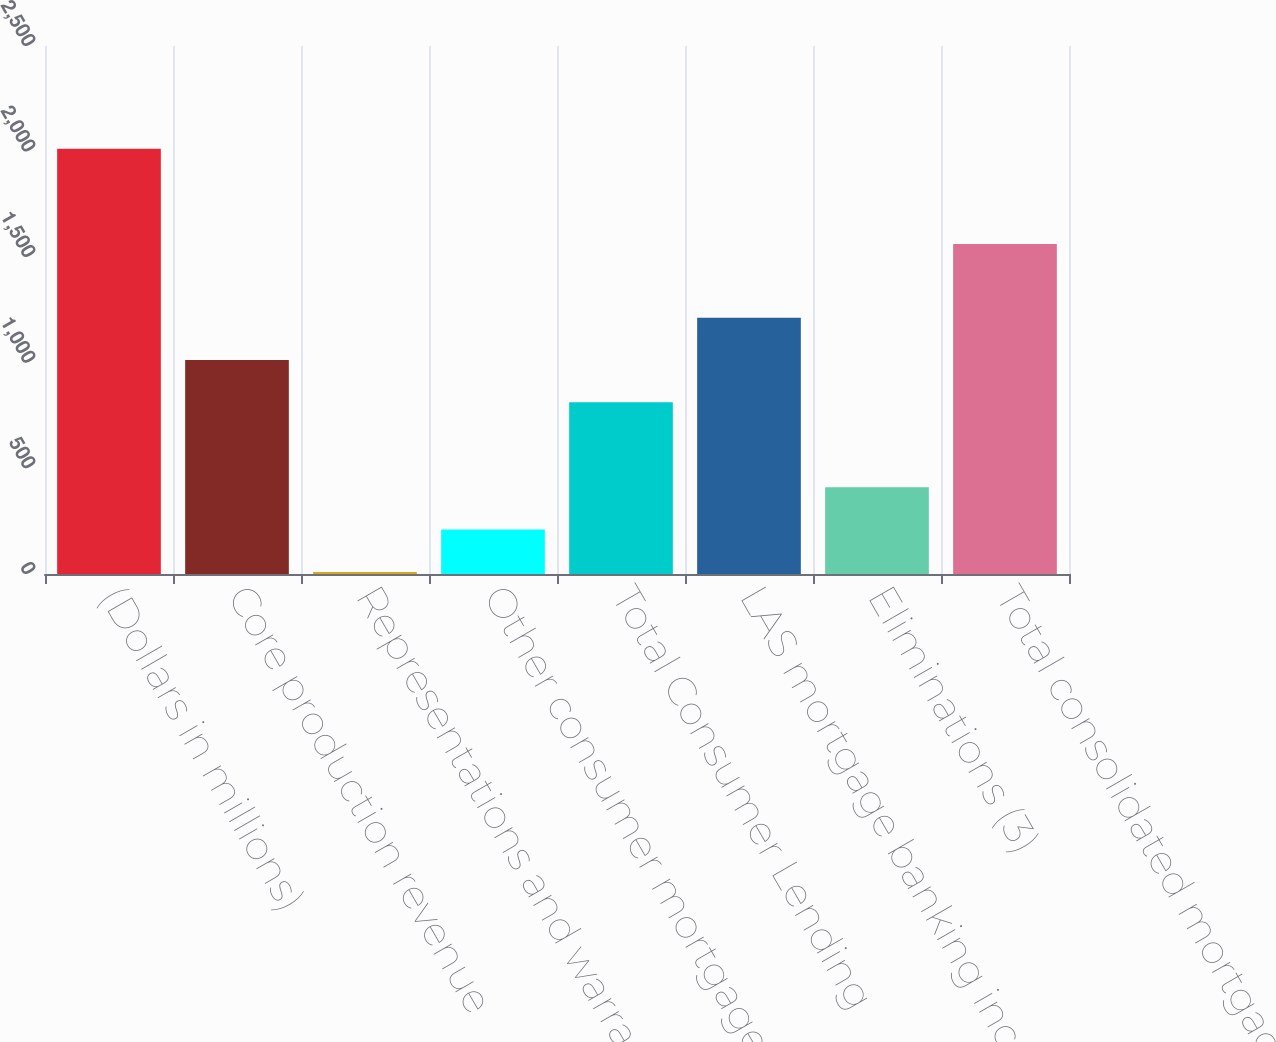<chart> <loc_0><loc_0><loc_500><loc_500><bar_chart><fcel>(Dollars in millions)<fcel>Core production revenue<fcel>Representations and warranties<fcel>Other consumer mortgage<fcel>Total Consumer Lending<fcel>LAS mortgage banking income<fcel>Eliminations (3)<fcel>Total consolidated mortgage<nl><fcel>2014<fcel>1013.4<fcel>10<fcel>210.4<fcel>813<fcel>1213.8<fcel>410.8<fcel>1563<nl></chart> 